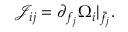<formula> <loc_0><loc_0><loc_500><loc_500>\mathcal { J } _ { i j } = \partial _ { f _ { j } } \Omega _ { i } | _ { \bar { f } _ { j } } .</formula> 